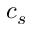Convert formula to latex. <formula><loc_0><loc_0><loc_500><loc_500>c _ { s }</formula> 